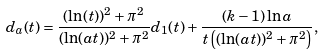<formula> <loc_0><loc_0><loc_500><loc_500>d _ { a } ( t ) = \frac { ( \ln ( t ) ) ^ { 2 } + \pi ^ { 2 } } { ( \ln ( a t ) ) ^ { 2 } + \pi ^ { 2 } } d _ { 1 } ( t ) + \frac { ( k - 1 ) \ln a } { t \left ( ( \ln ( a t ) ) ^ { 2 } + \pi ^ { 2 } \right ) } ,</formula> 